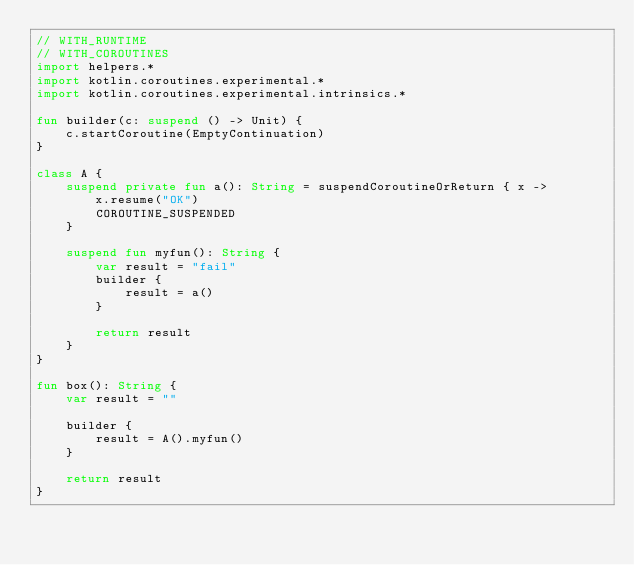Convert code to text. <code><loc_0><loc_0><loc_500><loc_500><_Kotlin_>// WITH_RUNTIME
// WITH_COROUTINES
import helpers.*
import kotlin.coroutines.experimental.*
import kotlin.coroutines.experimental.intrinsics.*

fun builder(c: suspend () -> Unit) {
    c.startCoroutine(EmptyContinuation)
}

class A {
    suspend private fun a(): String = suspendCoroutineOrReturn { x ->
        x.resume("OK")
        COROUTINE_SUSPENDED
    }

    suspend fun myfun(): String {
        var result = "fail"
        builder {
            result = a()
        }

        return result
    }
}

fun box(): String {
    var result = ""

    builder {
        result = A().myfun()
    }

    return result
}
</code> 